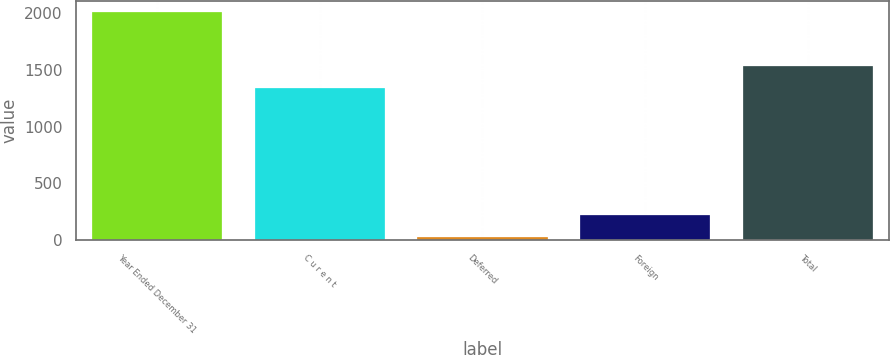Convert chart. <chart><loc_0><loc_0><loc_500><loc_500><bar_chart><fcel>Year Ended December 31<fcel>C u r e n t<fcel>Deferred<fcel>Foreign<fcel>Total<nl><fcel>2007<fcel>1340<fcel>27<fcel>225<fcel>1538<nl></chart> 